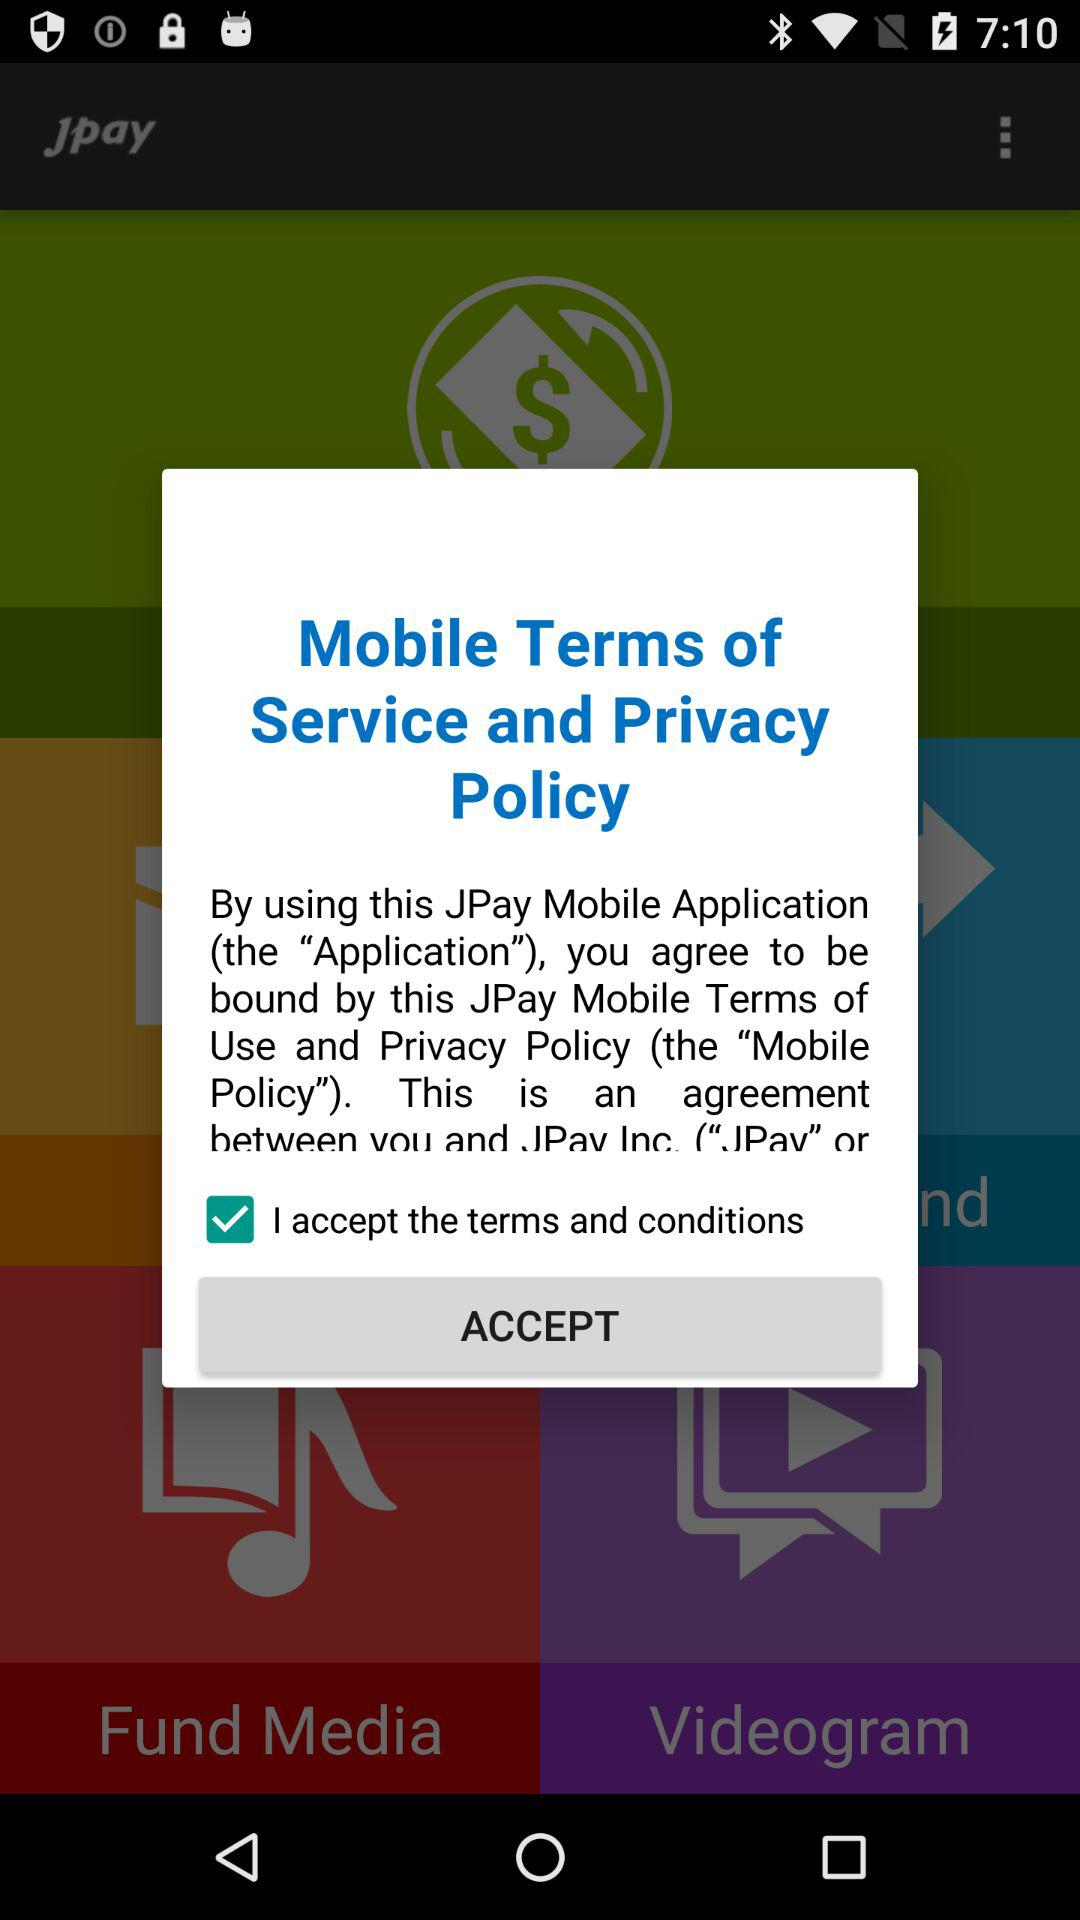What is the status of the option that includes acceptance to the “terms" and "conditions"? The status of the option that includes acceptance to the "terms" and "conditions" is "on". 